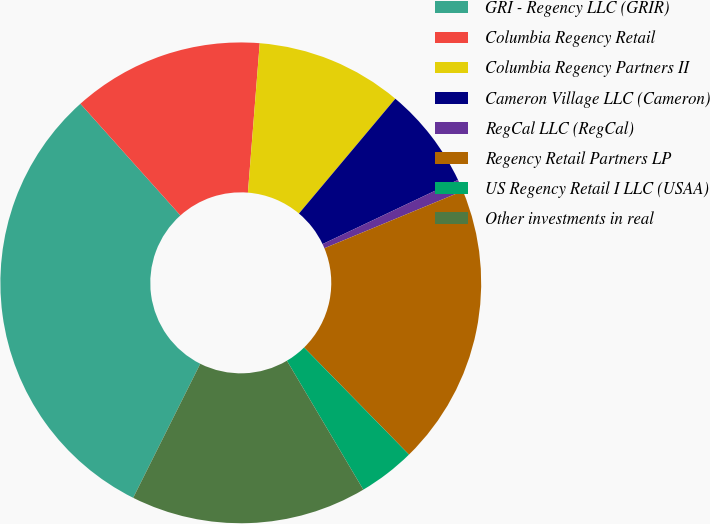<chart> <loc_0><loc_0><loc_500><loc_500><pie_chart><fcel>GRI - Regency LLC (GRIR)<fcel>Columbia Regency Retail<fcel>Columbia Regency Partners II<fcel>Cameron Village LLC (Cameron)<fcel>RegCal LLC (RegCal)<fcel>Regency Retail Partners LP<fcel>US Regency Retail I LLC (USAA)<fcel>Other investments in real<nl><fcel>30.99%<fcel>12.88%<fcel>9.86%<fcel>6.84%<fcel>0.8%<fcel>18.91%<fcel>3.82%<fcel>15.9%<nl></chart> 